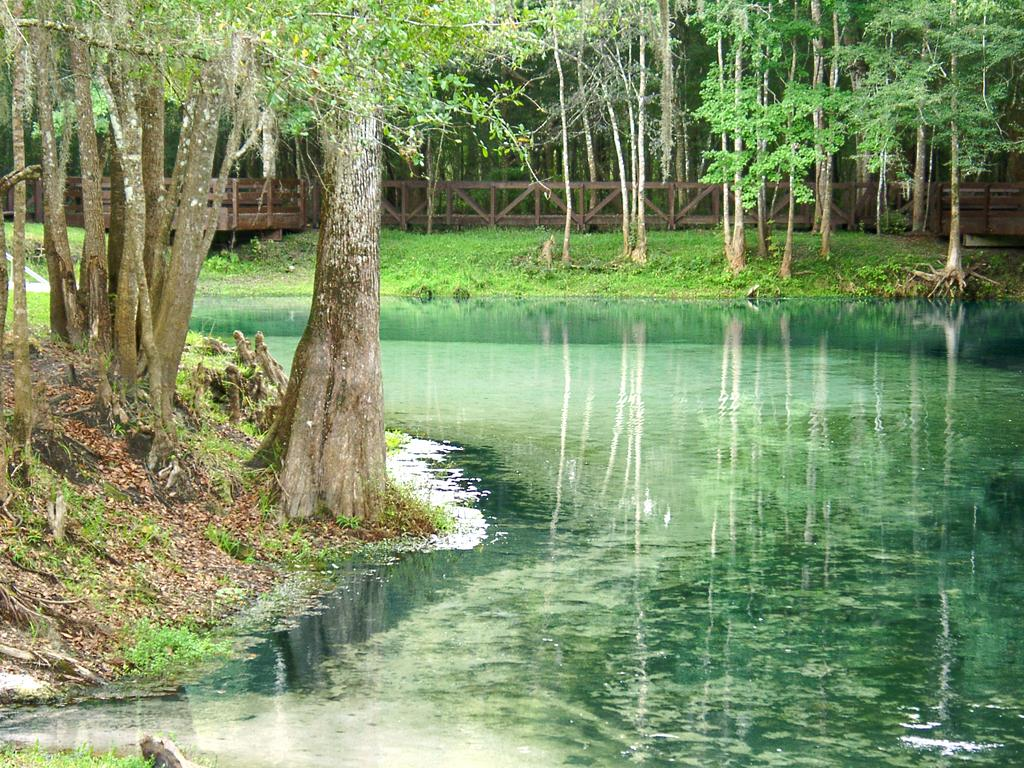What natural element can be seen in the image? Water is visible in the image. What type of vegetation is present in the image? There is grass and trees in the image. What man-made structure can be seen in the image? There is a fence in the image. How many fish can be seen swimming in the water in the image? There are no fish visible in the image; it only shows water, grass, a fence, and trees. 